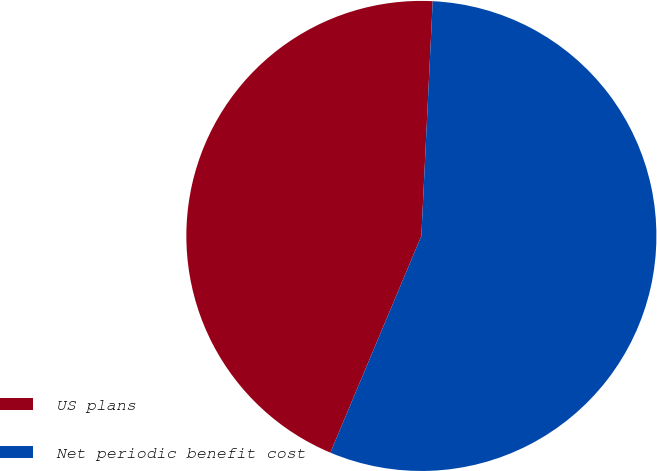Convert chart. <chart><loc_0><loc_0><loc_500><loc_500><pie_chart><fcel>US plans<fcel>Net periodic benefit cost<nl><fcel>44.44%<fcel>55.56%<nl></chart> 